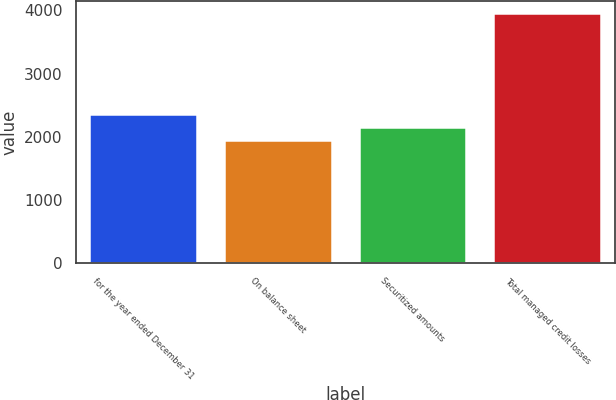Convert chart to OTSL. <chart><loc_0><loc_0><loc_500><loc_500><bar_chart><fcel>for the year ended December 31<fcel>On balance sheet<fcel>Securitized amounts<fcel>Total managed credit losses<nl><fcel>2355<fcel>1956<fcel>2155.5<fcel>3951<nl></chart> 